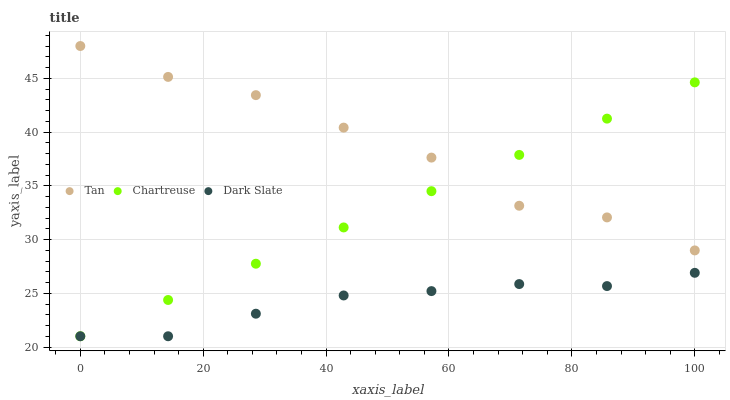Does Dark Slate have the minimum area under the curve?
Answer yes or no. Yes. Does Tan have the maximum area under the curve?
Answer yes or no. Yes. Does Chartreuse have the minimum area under the curve?
Answer yes or no. No. Does Chartreuse have the maximum area under the curve?
Answer yes or no. No. Is Chartreuse the smoothest?
Answer yes or no. Yes. Is Tan the roughest?
Answer yes or no. Yes. Is Tan the smoothest?
Answer yes or no. No. Is Chartreuse the roughest?
Answer yes or no. No. Does Dark Slate have the lowest value?
Answer yes or no. Yes. Does Tan have the lowest value?
Answer yes or no. No. Does Tan have the highest value?
Answer yes or no. Yes. Does Chartreuse have the highest value?
Answer yes or no. No. Is Dark Slate less than Tan?
Answer yes or no. Yes. Is Tan greater than Dark Slate?
Answer yes or no. Yes. Does Dark Slate intersect Chartreuse?
Answer yes or no. Yes. Is Dark Slate less than Chartreuse?
Answer yes or no. No. Is Dark Slate greater than Chartreuse?
Answer yes or no. No. Does Dark Slate intersect Tan?
Answer yes or no. No. 